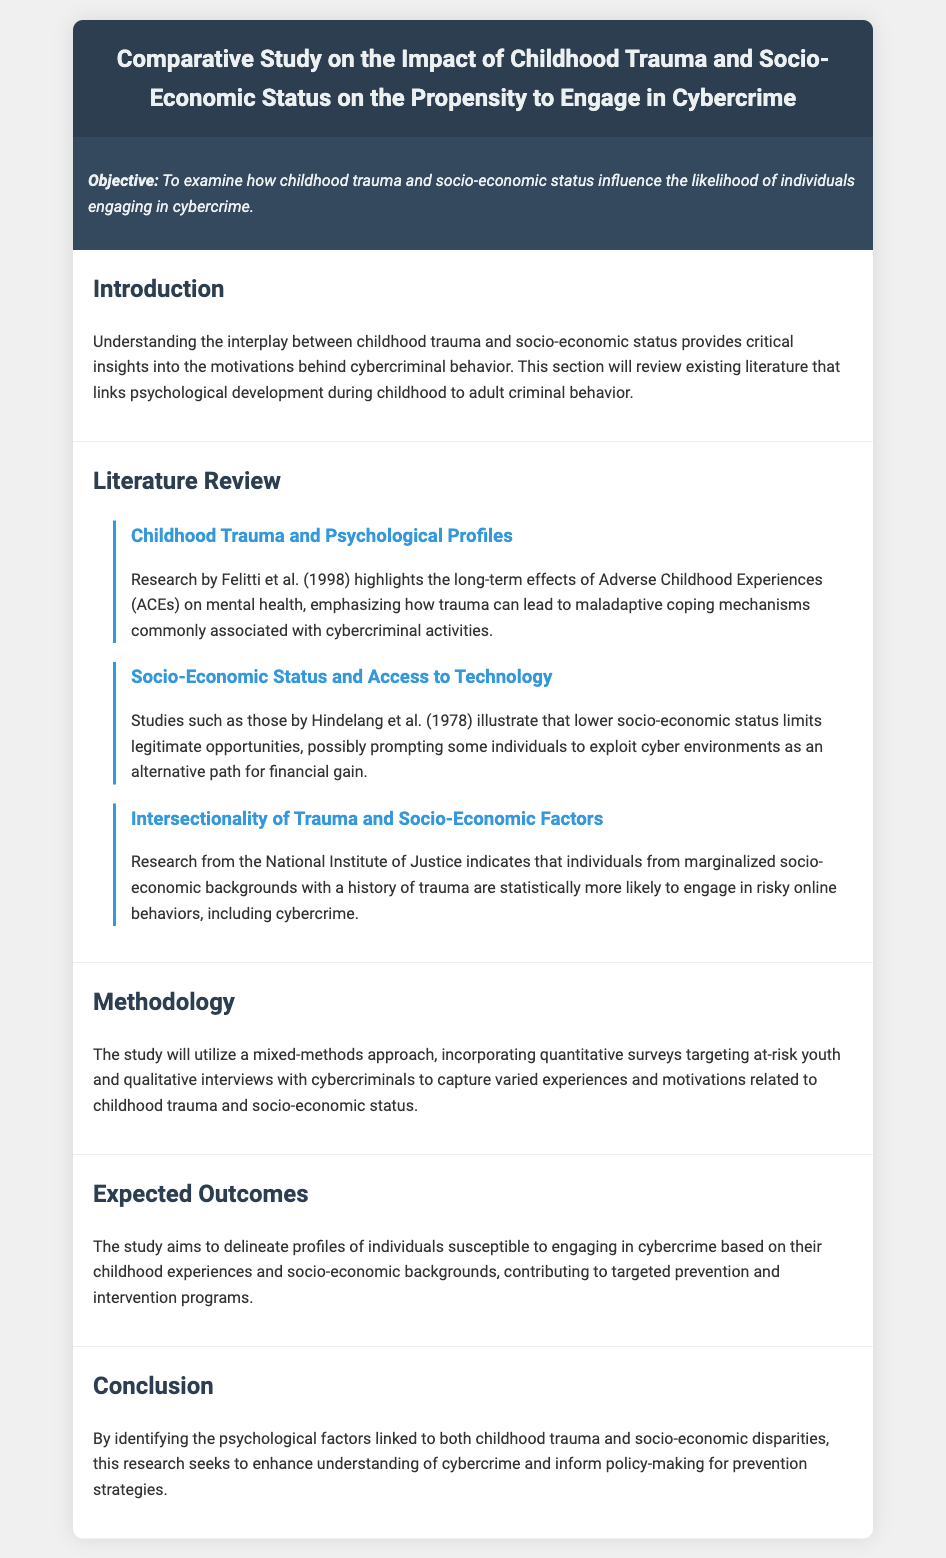What is the title of the study? The title is provided in the heading of the document.
Answer: Comparative Study on the Impact of Childhood Trauma and Socio-Economic Status on the Propensity to Engage in Cybercrime What is the objective of the study? The objective is stated in the objective section of the document.
Answer: To examine how childhood trauma and socio-economic status influence the likelihood of individuals engaging in cybercrime Who conducted research highlighting the effects of Adverse Childhood Experiences? The document references the researchers involved in the study of childhood trauma.
Answer: Felitti et al What methodology will the study utilize? The methodology is described in the corresponding section of the document.
Answer: A mixed-methods approach What are the expected outcomes of the study? The expected outcomes are outlined in their designated section.
Answer: Profiles of individuals susceptible to engaging in cybercrime Which section reviews existing literature? The literature review section is specifically mentioned in the agenda.
Answer: Literature Review How many subsections are under the Literature Review? The document lists how many subsections there are under this section.
Answer: Three What is one psychological factor mentioned that influences cybercrime? The document provides insights into psychological factors related to cybercrime.
Answer: Childhood trauma Which organization provided research on the intersectionality of trauma and socio-economic factors? The document cites the organization responsible for this research.
Answer: National Institute of Justice 